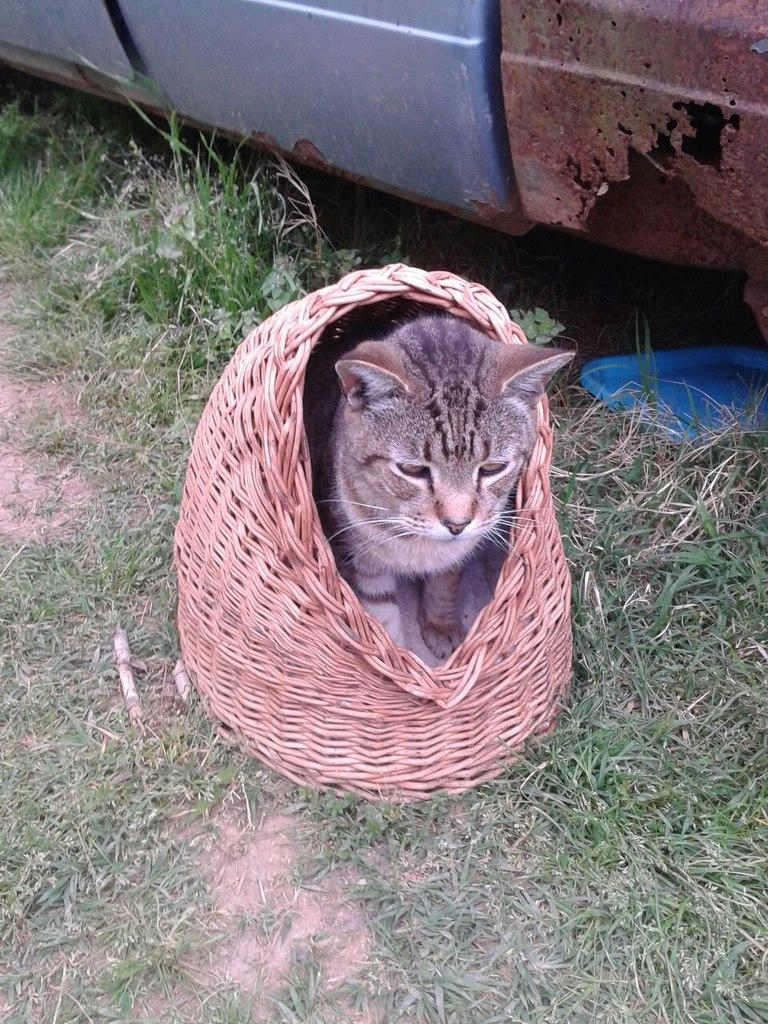What animal can be seen in the image? There is a cat in the image. Where is the cat located? The cat is standing in a wooden basket. What is the wooden basket placed on? The wooden basket is placed on the ground. What type of vegetation is present on the ground? Grass is present on the ground. What else can be seen near the wooden basket? There is a vehicle beside the wooden basket. What type of comparison can be made between the cat and the design of the field? There is no field present in the image, so no comparison can be made between the cat and the design of a field. 